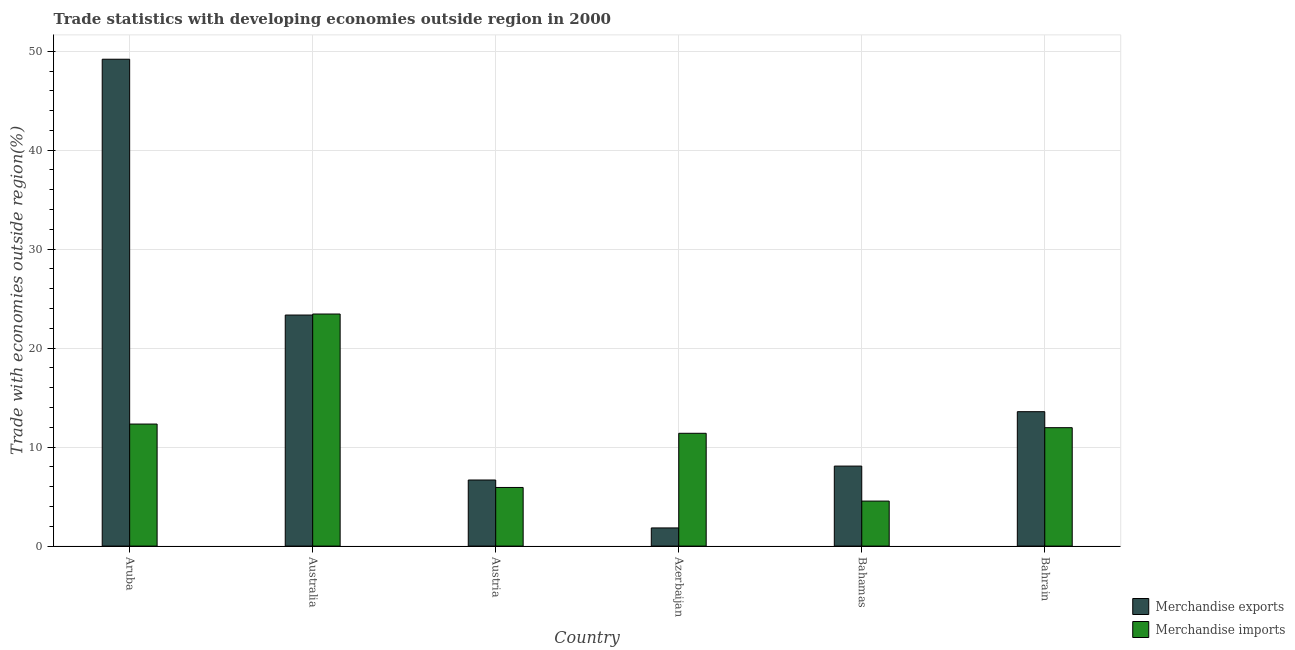How many groups of bars are there?
Provide a short and direct response. 6. Are the number of bars per tick equal to the number of legend labels?
Your response must be concise. Yes. How many bars are there on the 2nd tick from the left?
Offer a terse response. 2. How many bars are there on the 5th tick from the right?
Offer a terse response. 2. In how many cases, is the number of bars for a given country not equal to the number of legend labels?
Make the answer very short. 0. What is the merchandise imports in Bahamas?
Your answer should be compact. 4.55. Across all countries, what is the maximum merchandise imports?
Ensure brevity in your answer.  23.45. Across all countries, what is the minimum merchandise imports?
Offer a terse response. 4.55. In which country was the merchandise imports maximum?
Provide a succinct answer. Australia. In which country was the merchandise imports minimum?
Your response must be concise. Bahamas. What is the total merchandise imports in the graph?
Provide a succinct answer. 69.61. What is the difference between the merchandise exports in Aruba and that in Australia?
Offer a terse response. 25.85. What is the difference between the merchandise exports in Australia and the merchandise imports in Austria?
Offer a very short reply. 17.42. What is the average merchandise imports per country?
Offer a very short reply. 11.6. What is the difference between the merchandise exports and merchandise imports in Azerbaijan?
Give a very brief answer. -9.56. What is the ratio of the merchandise exports in Austria to that in Bahamas?
Make the answer very short. 0.83. Is the difference between the merchandise imports in Bahamas and Bahrain greater than the difference between the merchandise exports in Bahamas and Bahrain?
Offer a terse response. No. What is the difference between the highest and the second highest merchandise exports?
Ensure brevity in your answer.  25.85. What is the difference between the highest and the lowest merchandise exports?
Your answer should be very brief. 47.36. In how many countries, is the merchandise exports greater than the average merchandise exports taken over all countries?
Your answer should be compact. 2. Is the sum of the merchandise imports in Australia and Bahamas greater than the maximum merchandise exports across all countries?
Offer a terse response. No. What does the 1st bar from the left in Austria represents?
Give a very brief answer. Merchandise exports. Are all the bars in the graph horizontal?
Give a very brief answer. No. Are the values on the major ticks of Y-axis written in scientific E-notation?
Your answer should be compact. No. Does the graph contain any zero values?
Offer a terse response. No. How many legend labels are there?
Keep it short and to the point. 2. What is the title of the graph?
Provide a succinct answer. Trade statistics with developing economies outside region in 2000. Does "Fixed telephone" appear as one of the legend labels in the graph?
Give a very brief answer. No. What is the label or title of the Y-axis?
Give a very brief answer. Trade with economies outside region(%). What is the Trade with economies outside region(%) of Merchandise exports in Aruba?
Provide a short and direct response. 49.19. What is the Trade with economies outside region(%) of Merchandise imports in Aruba?
Give a very brief answer. 12.33. What is the Trade with economies outside region(%) of Merchandise exports in Australia?
Keep it short and to the point. 23.34. What is the Trade with economies outside region(%) in Merchandise imports in Australia?
Offer a very short reply. 23.45. What is the Trade with economies outside region(%) in Merchandise exports in Austria?
Offer a terse response. 6.68. What is the Trade with economies outside region(%) in Merchandise imports in Austria?
Offer a terse response. 5.92. What is the Trade with economies outside region(%) in Merchandise exports in Azerbaijan?
Your answer should be compact. 1.84. What is the Trade with economies outside region(%) in Merchandise imports in Azerbaijan?
Offer a terse response. 11.4. What is the Trade with economies outside region(%) in Merchandise exports in Bahamas?
Your answer should be very brief. 8.08. What is the Trade with economies outside region(%) of Merchandise imports in Bahamas?
Your answer should be compact. 4.55. What is the Trade with economies outside region(%) of Merchandise exports in Bahrain?
Keep it short and to the point. 13.58. What is the Trade with economies outside region(%) in Merchandise imports in Bahrain?
Ensure brevity in your answer.  11.97. Across all countries, what is the maximum Trade with economies outside region(%) of Merchandise exports?
Offer a terse response. 49.19. Across all countries, what is the maximum Trade with economies outside region(%) of Merchandise imports?
Your answer should be very brief. 23.45. Across all countries, what is the minimum Trade with economies outside region(%) in Merchandise exports?
Ensure brevity in your answer.  1.84. Across all countries, what is the minimum Trade with economies outside region(%) of Merchandise imports?
Provide a succinct answer. 4.55. What is the total Trade with economies outside region(%) in Merchandise exports in the graph?
Your answer should be compact. 102.71. What is the total Trade with economies outside region(%) of Merchandise imports in the graph?
Provide a short and direct response. 69.61. What is the difference between the Trade with economies outside region(%) of Merchandise exports in Aruba and that in Australia?
Your answer should be compact. 25.85. What is the difference between the Trade with economies outside region(%) of Merchandise imports in Aruba and that in Australia?
Your answer should be compact. -11.12. What is the difference between the Trade with economies outside region(%) of Merchandise exports in Aruba and that in Austria?
Provide a short and direct response. 42.51. What is the difference between the Trade with economies outside region(%) in Merchandise imports in Aruba and that in Austria?
Keep it short and to the point. 6.41. What is the difference between the Trade with economies outside region(%) in Merchandise exports in Aruba and that in Azerbaijan?
Ensure brevity in your answer.  47.36. What is the difference between the Trade with economies outside region(%) in Merchandise imports in Aruba and that in Azerbaijan?
Give a very brief answer. 0.93. What is the difference between the Trade with economies outside region(%) in Merchandise exports in Aruba and that in Bahamas?
Your answer should be compact. 41.11. What is the difference between the Trade with economies outside region(%) in Merchandise imports in Aruba and that in Bahamas?
Provide a succinct answer. 7.78. What is the difference between the Trade with economies outside region(%) in Merchandise exports in Aruba and that in Bahrain?
Provide a short and direct response. 35.61. What is the difference between the Trade with economies outside region(%) in Merchandise imports in Aruba and that in Bahrain?
Offer a terse response. 0.37. What is the difference between the Trade with economies outside region(%) in Merchandise exports in Australia and that in Austria?
Your answer should be very brief. 16.67. What is the difference between the Trade with economies outside region(%) of Merchandise imports in Australia and that in Austria?
Ensure brevity in your answer.  17.52. What is the difference between the Trade with economies outside region(%) of Merchandise exports in Australia and that in Azerbaijan?
Your answer should be compact. 21.51. What is the difference between the Trade with economies outside region(%) in Merchandise imports in Australia and that in Azerbaijan?
Your answer should be very brief. 12.05. What is the difference between the Trade with economies outside region(%) in Merchandise exports in Australia and that in Bahamas?
Provide a short and direct response. 15.26. What is the difference between the Trade with economies outside region(%) of Merchandise imports in Australia and that in Bahamas?
Keep it short and to the point. 18.9. What is the difference between the Trade with economies outside region(%) in Merchandise exports in Australia and that in Bahrain?
Offer a terse response. 9.76. What is the difference between the Trade with economies outside region(%) in Merchandise imports in Australia and that in Bahrain?
Make the answer very short. 11.48. What is the difference between the Trade with economies outside region(%) in Merchandise exports in Austria and that in Azerbaijan?
Provide a short and direct response. 4.84. What is the difference between the Trade with economies outside region(%) in Merchandise imports in Austria and that in Azerbaijan?
Provide a succinct answer. -5.47. What is the difference between the Trade with economies outside region(%) in Merchandise exports in Austria and that in Bahamas?
Your answer should be compact. -1.41. What is the difference between the Trade with economies outside region(%) in Merchandise imports in Austria and that in Bahamas?
Offer a very short reply. 1.38. What is the difference between the Trade with economies outside region(%) in Merchandise exports in Austria and that in Bahrain?
Offer a very short reply. -6.9. What is the difference between the Trade with economies outside region(%) of Merchandise imports in Austria and that in Bahrain?
Offer a very short reply. -6.04. What is the difference between the Trade with economies outside region(%) of Merchandise exports in Azerbaijan and that in Bahamas?
Your answer should be compact. -6.25. What is the difference between the Trade with economies outside region(%) in Merchandise imports in Azerbaijan and that in Bahamas?
Your answer should be compact. 6.85. What is the difference between the Trade with economies outside region(%) in Merchandise exports in Azerbaijan and that in Bahrain?
Offer a very short reply. -11.75. What is the difference between the Trade with economies outside region(%) of Merchandise imports in Azerbaijan and that in Bahrain?
Offer a terse response. -0.57. What is the difference between the Trade with economies outside region(%) of Merchandise exports in Bahamas and that in Bahrain?
Offer a terse response. -5.5. What is the difference between the Trade with economies outside region(%) in Merchandise imports in Bahamas and that in Bahrain?
Give a very brief answer. -7.42. What is the difference between the Trade with economies outside region(%) in Merchandise exports in Aruba and the Trade with economies outside region(%) in Merchandise imports in Australia?
Your answer should be very brief. 25.74. What is the difference between the Trade with economies outside region(%) in Merchandise exports in Aruba and the Trade with economies outside region(%) in Merchandise imports in Austria?
Your answer should be very brief. 43.27. What is the difference between the Trade with economies outside region(%) in Merchandise exports in Aruba and the Trade with economies outside region(%) in Merchandise imports in Azerbaijan?
Ensure brevity in your answer.  37.79. What is the difference between the Trade with economies outside region(%) in Merchandise exports in Aruba and the Trade with economies outside region(%) in Merchandise imports in Bahamas?
Ensure brevity in your answer.  44.64. What is the difference between the Trade with economies outside region(%) of Merchandise exports in Aruba and the Trade with economies outside region(%) of Merchandise imports in Bahrain?
Make the answer very short. 37.23. What is the difference between the Trade with economies outside region(%) in Merchandise exports in Australia and the Trade with economies outside region(%) in Merchandise imports in Austria?
Offer a very short reply. 17.42. What is the difference between the Trade with economies outside region(%) of Merchandise exports in Australia and the Trade with economies outside region(%) of Merchandise imports in Azerbaijan?
Give a very brief answer. 11.95. What is the difference between the Trade with economies outside region(%) in Merchandise exports in Australia and the Trade with economies outside region(%) in Merchandise imports in Bahamas?
Give a very brief answer. 18.8. What is the difference between the Trade with economies outside region(%) of Merchandise exports in Australia and the Trade with economies outside region(%) of Merchandise imports in Bahrain?
Provide a succinct answer. 11.38. What is the difference between the Trade with economies outside region(%) in Merchandise exports in Austria and the Trade with economies outside region(%) in Merchandise imports in Azerbaijan?
Give a very brief answer. -4.72. What is the difference between the Trade with economies outside region(%) of Merchandise exports in Austria and the Trade with economies outside region(%) of Merchandise imports in Bahamas?
Make the answer very short. 2.13. What is the difference between the Trade with economies outside region(%) of Merchandise exports in Austria and the Trade with economies outside region(%) of Merchandise imports in Bahrain?
Your response must be concise. -5.29. What is the difference between the Trade with economies outside region(%) of Merchandise exports in Azerbaijan and the Trade with economies outside region(%) of Merchandise imports in Bahamas?
Give a very brief answer. -2.71. What is the difference between the Trade with economies outside region(%) in Merchandise exports in Azerbaijan and the Trade with economies outside region(%) in Merchandise imports in Bahrain?
Offer a terse response. -10.13. What is the difference between the Trade with economies outside region(%) of Merchandise exports in Bahamas and the Trade with economies outside region(%) of Merchandise imports in Bahrain?
Offer a very short reply. -3.88. What is the average Trade with economies outside region(%) of Merchandise exports per country?
Offer a very short reply. 17.12. What is the average Trade with economies outside region(%) of Merchandise imports per country?
Give a very brief answer. 11.6. What is the difference between the Trade with economies outside region(%) of Merchandise exports and Trade with economies outside region(%) of Merchandise imports in Aruba?
Provide a succinct answer. 36.86. What is the difference between the Trade with economies outside region(%) of Merchandise exports and Trade with economies outside region(%) of Merchandise imports in Australia?
Provide a succinct answer. -0.1. What is the difference between the Trade with economies outside region(%) of Merchandise exports and Trade with economies outside region(%) of Merchandise imports in Austria?
Ensure brevity in your answer.  0.75. What is the difference between the Trade with economies outside region(%) in Merchandise exports and Trade with economies outside region(%) in Merchandise imports in Azerbaijan?
Offer a very short reply. -9.56. What is the difference between the Trade with economies outside region(%) in Merchandise exports and Trade with economies outside region(%) in Merchandise imports in Bahamas?
Your answer should be very brief. 3.53. What is the difference between the Trade with economies outside region(%) of Merchandise exports and Trade with economies outside region(%) of Merchandise imports in Bahrain?
Make the answer very short. 1.62. What is the ratio of the Trade with economies outside region(%) of Merchandise exports in Aruba to that in Australia?
Offer a terse response. 2.11. What is the ratio of the Trade with economies outside region(%) in Merchandise imports in Aruba to that in Australia?
Your answer should be compact. 0.53. What is the ratio of the Trade with economies outside region(%) in Merchandise exports in Aruba to that in Austria?
Ensure brevity in your answer.  7.37. What is the ratio of the Trade with economies outside region(%) of Merchandise imports in Aruba to that in Austria?
Provide a short and direct response. 2.08. What is the ratio of the Trade with economies outside region(%) of Merchandise exports in Aruba to that in Azerbaijan?
Ensure brevity in your answer.  26.8. What is the ratio of the Trade with economies outside region(%) of Merchandise imports in Aruba to that in Azerbaijan?
Your answer should be very brief. 1.08. What is the ratio of the Trade with economies outside region(%) of Merchandise exports in Aruba to that in Bahamas?
Give a very brief answer. 6.09. What is the ratio of the Trade with economies outside region(%) in Merchandise imports in Aruba to that in Bahamas?
Provide a succinct answer. 2.71. What is the ratio of the Trade with economies outside region(%) of Merchandise exports in Aruba to that in Bahrain?
Your answer should be very brief. 3.62. What is the ratio of the Trade with economies outside region(%) in Merchandise imports in Aruba to that in Bahrain?
Offer a terse response. 1.03. What is the ratio of the Trade with economies outside region(%) of Merchandise exports in Australia to that in Austria?
Ensure brevity in your answer.  3.5. What is the ratio of the Trade with economies outside region(%) of Merchandise imports in Australia to that in Austria?
Give a very brief answer. 3.96. What is the ratio of the Trade with economies outside region(%) in Merchandise exports in Australia to that in Azerbaijan?
Offer a terse response. 12.72. What is the ratio of the Trade with economies outside region(%) of Merchandise imports in Australia to that in Azerbaijan?
Provide a succinct answer. 2.06. What is the ratio of the Trade with economies outside region(%) in Merchandise exports in Australia to that in Bahamas?
Make the answer very short. 2.89. What is the ratio of the Trade with economies outside region(%) in Merchandise imports in Australia to that in Bahamas?
Your answer should be compact. 5.15. What is the ratio of the Trade with economies outside region(%) of Merchandise exports in Australia to that in Bahrain?
Keep it short and to the point. 1.72. What is the ratio of the Trade with economies outside region(%) of Merchandise imports in Australia to that in Bahrain?
Offer a terse response. 1.96. What is the ratio of the Trade with economies outside region(%) of Merchandise exports in Austria to that in Azerbaijan?
Make the answer very short. 3.64. What is the ratio of the Trade with economies outside region(%) in Merchandise imports in Austria to that in Azerbaijan?
Give a very brief answer. 0.52. What is the ratio of the Trade with economies outside region(%) in Merchandise exports in Austria to that in Bahamas?
Provide a succinct answer. 0.83. What is the ratio of the Trade with economies outside region(%) in Merchandise imports in Austria to that in Bahamas?
Give a very brief answer. 1.3. What is the ratio of the Trade with economies outside region(%) in Merchandise exports in Austria to that in Bahrain?
Make the answer very short. 0.49. What is the ratio of the Trade with economies outside region(%) in Merchandise imports in Austria to that in Bahrain?
Your response must be concise. 0.5. What is the ratio of the Trade with economies outside region(%) in Merchandise exports in Azerbaijan to that in Bahamas?
Ensure brevity in your answer.  0.23. What is the ratio of the Trade with economies outside region(%) in Merchandise imports in Azerbaijan to that in Bahamas?
Offer a very short reply. 2.51. What is the ratio of the Trade with economies outside region(%) of Merchandise exports in Azerbaijan to that in Bahrain?
Offer a very short reply. 0.14. What is the ratio of the Trade with economies outside region(%) of Merchandise imports in Azerbaijan to that in Bahrain?
Your answer should be very brief. 0.95. What is the ratio of the Trade with economies outside region(%) in Merchandise exports in Bahamas to that in Bahrain?
Give a very brief answer. 0.6. What is the ratio of the Trade with economies outside region(%) of Merchandise imports in Bahamas to that in Bahrain?
Give a very brief answer. 0.38. What is the difference between the highest and the second highest Trade with economies outside region(%) of Merchandise exports?
Give a very brief answer. 25.85. What is the difference between the highest and the second highest Trade with economies outside region(%) in Merchandise imports?
Ensure brevity in your answer.  11.12. What is the difference between the highest and the lowest Trade with economies outside region(%) of Merchandise exports?
Your response must be concise. 47.36. What is the difference between the highest and the lowest Trade with economies outside region(%) in Merchandise imports?
Your response must be concise. 18.9. 